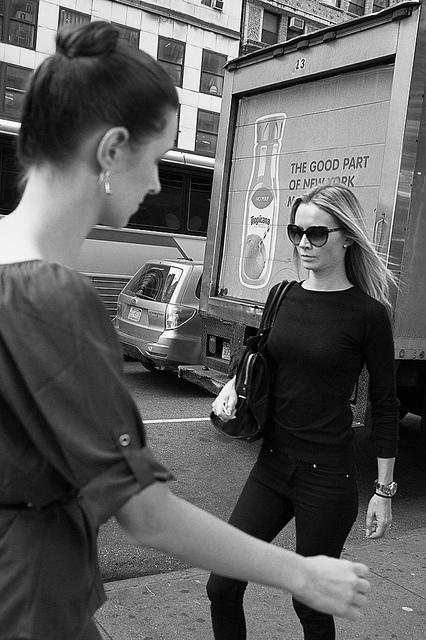Is this a welcoming person?
Answer briefly. No. How many women are wearing sunglasses?
Be succinct. 1. What is reflected on the buildings in the background?
Quick response, please. Nothing. Is this photo black and white?
Answer briefly. Yes. What drink is advertised in the background?
Concise answer only. Orange juice. 